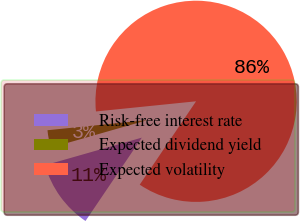Convert chart to OTSL. <chart><loc_0><loc_0><loc_500><loc_500><pie_chart><fcel>Risk-free interest rate<fcel>Expected dividend yield<fcel>Expected volatility<nl><fcel>11.12%<fcel>2.81%<fcel>86.06%<nl></chart> 